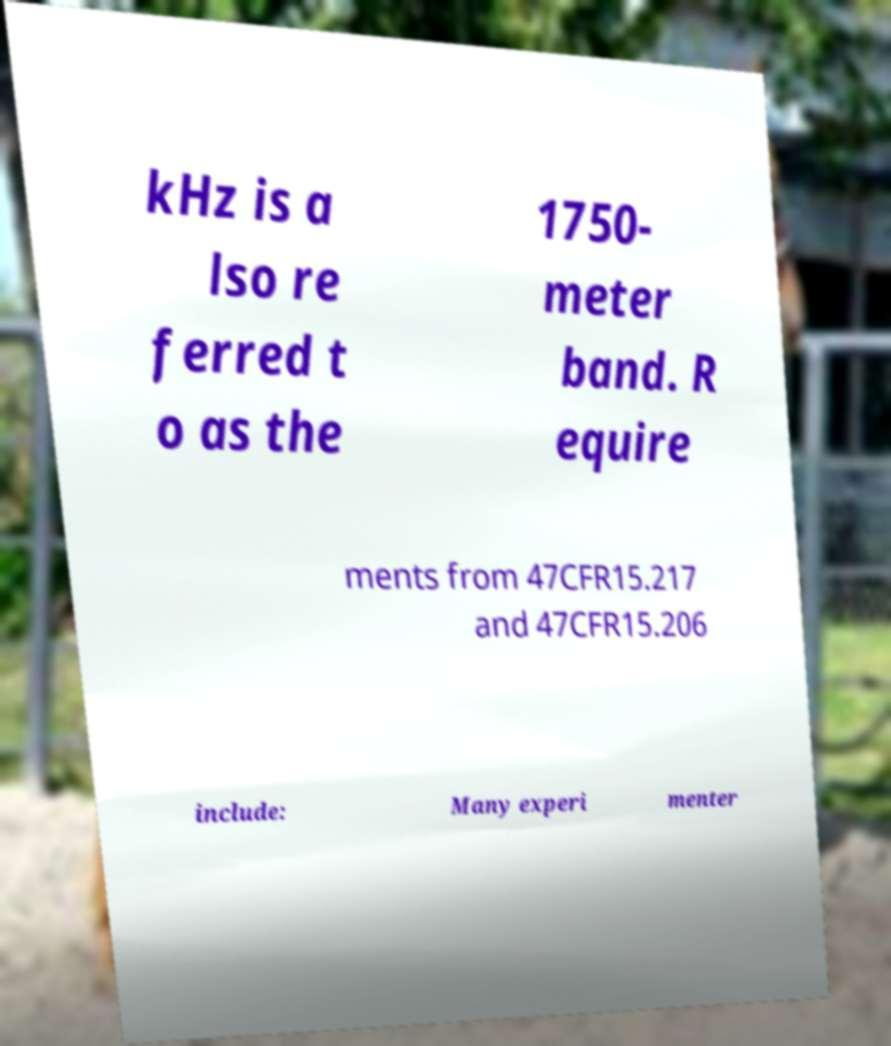For documentation purposes, I need the text within this image transcribed. Could you provide that? kHz is a lso re ferred t o as the 1750- meter band. R equire ments from 47CFR15.217 and 47CFR15.206 include: Many experi menter 